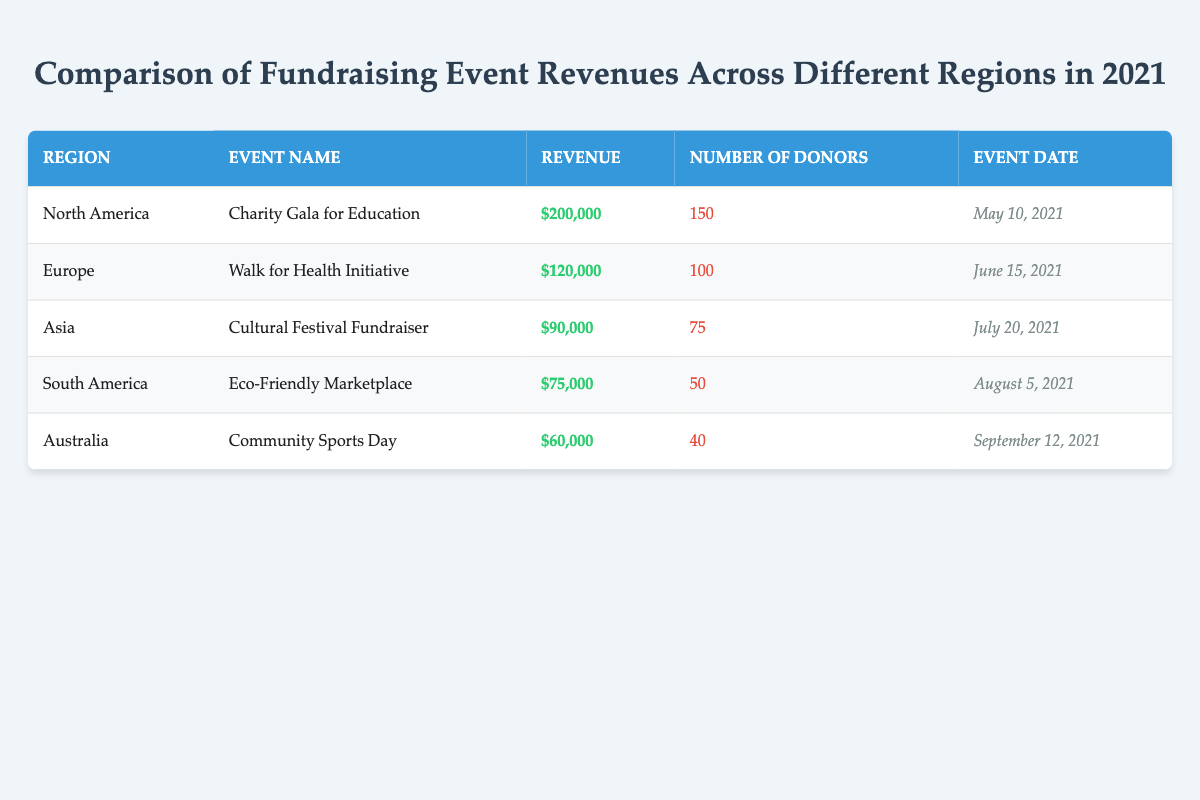What is the total revenue generated from all fundraising events? To find the total revenue, I need to add up the revenue from all the events listed in the table: 200000 + 120000 + 90000 + 75000 + 60000 = 575000.
Answer: 575000 Which region had the highest number of donors? The table lists the number of donors for each region. North America has 150 donors, Europe has 100, Asia has 75, South America has 50, and Australia has 40. Therefore, North America had the highest number of donors.
Answer: North America What is the average revenue from the fundraising events? To calculate the average revenue, I sum the revenues (200000 + 120000 + 90000 + 75000 + 60000 = 575000) and divide by the number of events (5): 575000 / 5 = 115000.
Answer: 115000 Did the event in South America generate more revenue than the event in Australia? The revenue for the event in South America (75000) is compared to that of Australia (60000). Since 75000 > 60000, the statement is true.
Answer: Yes What is the difference in revenue between the highest and lowest fundraising events? From the table, the highest revenue is 200000 (North America) and the lowest is 60000 (Australia). The difference is calculated as 200000 - 60000 = 140000.
Answer: 140000 Which fundraising event was held last in 2021? I will look at the event dates listed in the table. The event in Australia, "Community Sports Day," was held on September 12, 2021, making it the last event of the year.
Answer: Community Sports Day Is it true that Asia had more donors than South America? Asia had 75 donors, while South America had 50 donors. Since 75 > 50, it is true that Asia had more donors.
Answer: Yes What percentage of the total revenue was generated by North America? The revenue from North America is 200000. The total revenue is 575000. To find the percentage, calculate (200000 / 575000) * 100 = approximately 34.78%.
Answer: 34.78% What is the collective number of donors from Europe and Asia? The number of donors from Europe is 100 and from Asia is 75. Adding these two gives 100 + 75 = 175 donors as a collective total from these regions.
Answer: 175 